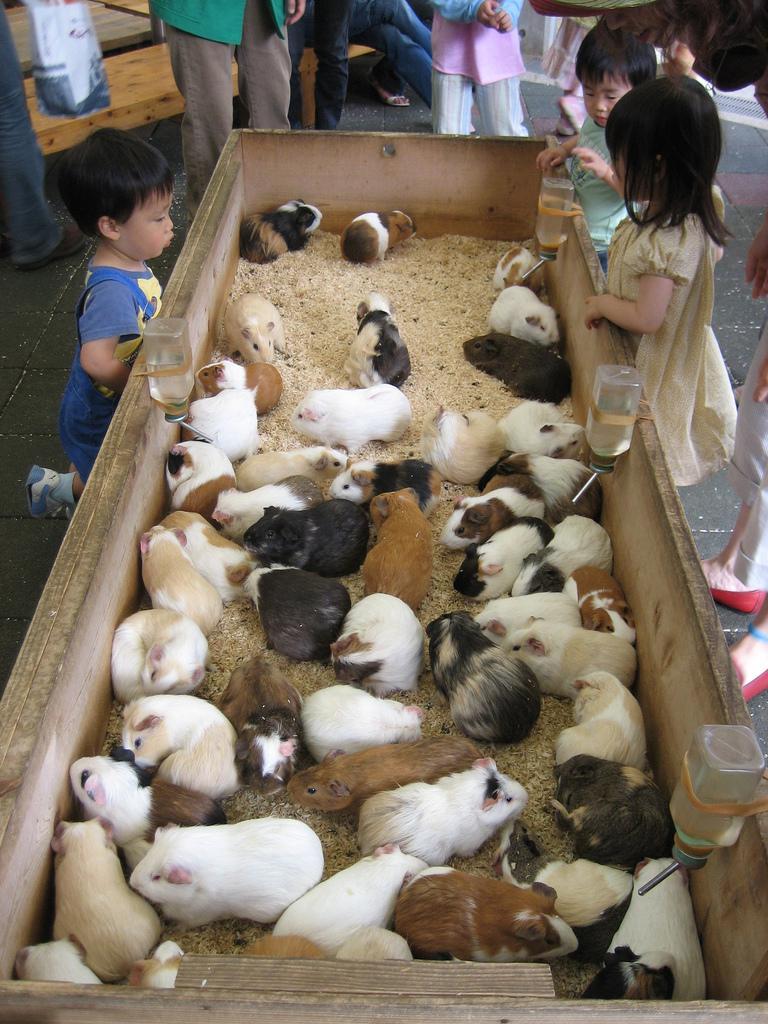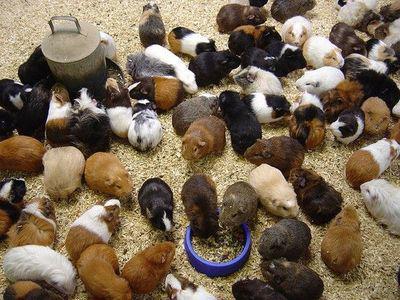The first image is the image on the left, the second image is the image on the right. Given the left and right images, does the statement "An image shows multiple guinea pigs around a bowl of food." hold true? Answer yes or no. Yes. The first image is the image on the left, the second image is the image on the right. Analyze the images presented: Is the assertion "Guinea pics are eating green hay." valid? Answer yes or no. No. 